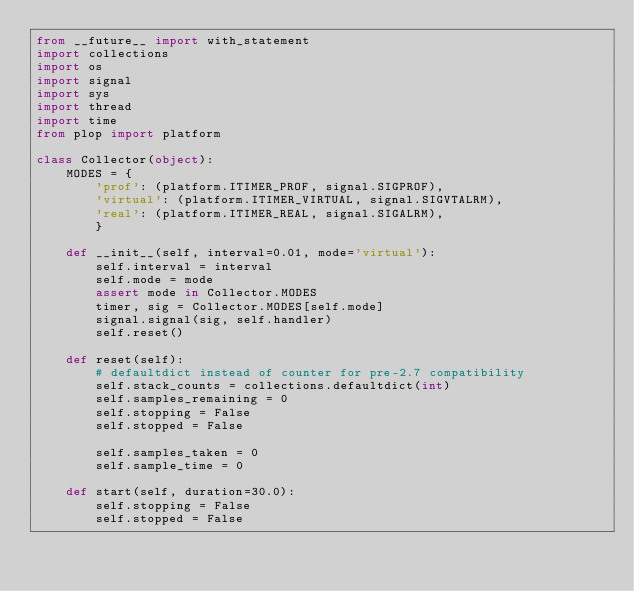<code> <loc_0><loc_0><loc_500><loc_500><_Python_>from __future__ import with_statement
import collections
import os
import signal
import sys
import thread
import time
from plop import platform

class Collector(object):
    MODES = {
        'prof': (platform.ITIMER_PROF, signal.SIGPROF),
        'virtual': (platform.ITIMER_VIRTUAL, signal.SIGVTALRM),
        'real': (platform.ITIMER_REAL, signal.SIGALRM),
        }

    def __init__(self, interval=0.01, mode='virtual'):
        self.interval = interval
        self.mode = mode
        assert mode in Collector.MODES
        timer, sig = Collector.MODES[self.mode]
        signal.signal(sig, self.handler)
        self.reset()

    def reset(self):
        # defaultdict instead of counter for pre-2.7 compatibility
        self.stack_counts = collections.defaultdict(int)
        self.samples_remaining = 0
        self.stopping = False
        self.stopped = False

        self.samples_taken = 0
        self.sample_time = 0

    def start(self, duration=30.0):
        self.stopping = False
        self.stopped = False</code> 